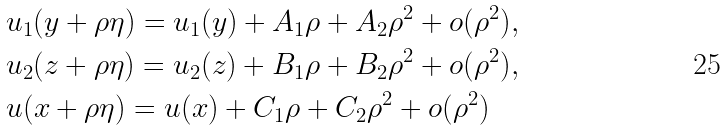<formula> <loc_0><loc_0><loc_500><loc_500>& u _ { 1 } ( y + \rho \eta ) = u _ { 1 } ( y ) + A _ { 1 } \rho + A _ { 2 } \rho ^ { 2 } + o ( \rho ^ { 2 } ) , \\ & u _ { 2 } ( z + \rho \eta ) = u _ { 2 } ( z ) + B _ { 1 } \rho + B _ { 2 } \rho ^ { 2 } + o ( \rho ^ { 2 } ) , \\ & u ( x + \rho \eta ) = u ( x ) + C _ { 1 } \rho + C _ { 2 } \rho ^ { 2 } + o ( \rho ^ { 2 } )</formula> 